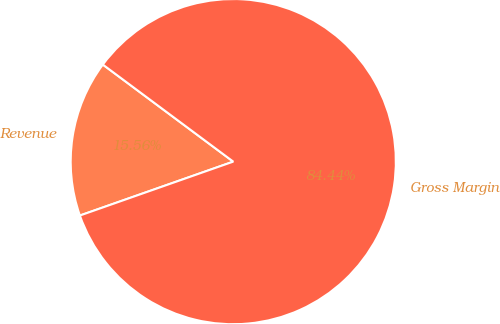<chart> <loc_0><loc_0><loc_500><loc_500><pie_chart><fcel>Revenue<fcel>Gross Margin<nl><fcel>15.56%<fcel>84.44%<nl></chart> 